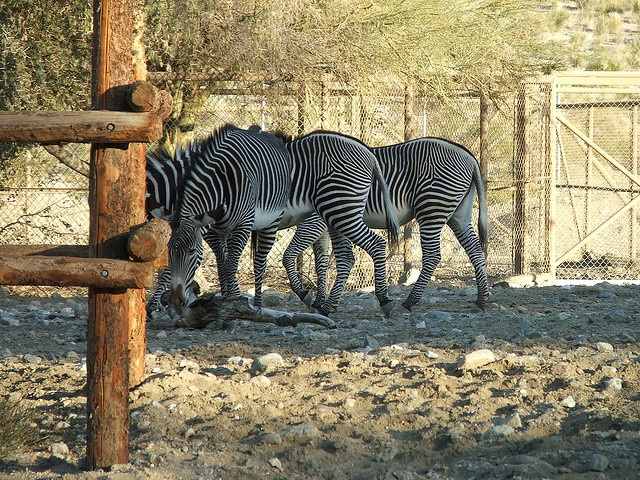Describe the objects in this image and their specific colors. I can see zebra in darkgreen, black, gray, and darkgray tones, zebra in darkgreen, black, gray, darkgray, and lightgray tones, and zebra in darkgreen, black, gray, darkgray, and tan tones in this image. 